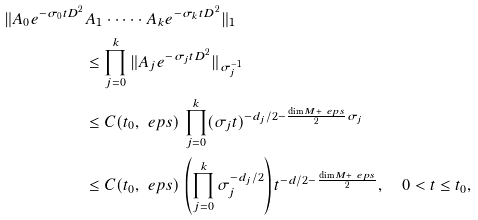Convert formula to latex. <formula><loc_0><loc_0><loc_500><loc_500>\| A _ { 0 } e ^ { - \sigma _ { 0 } t D ^ { 2 } } & A _ { 1 } \cdot \dots \cdot A _ { k } e ^ { - \sigma _ { k } t D ^ { 2 } } \| _ { 1 } \\ & \leq \prod _ { j = 0 } ^ { k } \| A _ { j } e ^ { - \sigma _ { j } t D ^ { 2 } } \| _ { \sigma _ { j } ^ { - 1 } } \\ & \leq C ( t _ { 0 } , \ e p s ) \, \prod _ { j = 0 } ^ { k } ( \sigma _ { j } t ) ^ { - d _ { j } / 2 - \frac { \dim M + \ e p s } { 2 } \sigma _ { j } } \\ & \leq C ( t _ { 0 } , \ e p s ) \, \left ( \prod _ { j = 0 } ^ { k } \sigma _ { j } ^ { - d _ { j } / 2 } \right ) t ^ { - d / 2 - \frac { \dim M + \ e p s } { 2 } } , \quad 0 < t \leq t _ { 0 } ,</formula> 